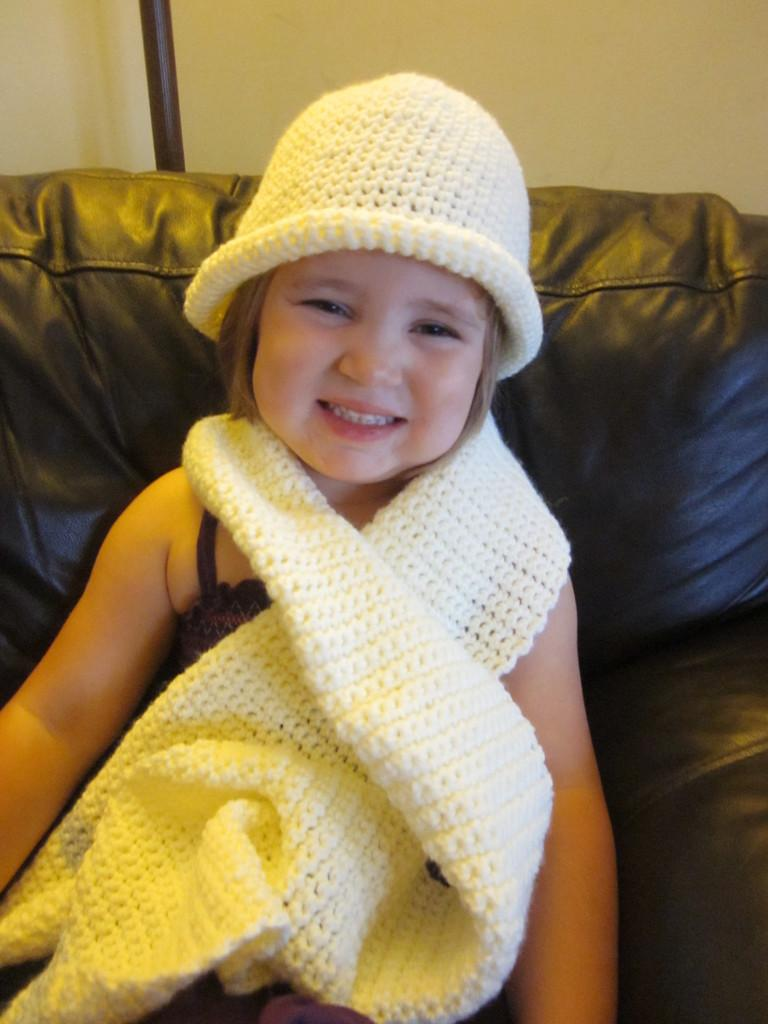Who is the main subject in the image? There is a girl in the image. What is the girl wearing? The girl is wearing a cap and a scarf. What is the girl's facial expression? The girl is smiling. Where is the girl sitting? The girl is sitting on a couch. What can be seen in the background of the image? There is a wall in the background of the image. What type of bait is the girl using to catch fish in the image? There is no indication in the image that the girl is using bait or attempting to catch fish. What does the girl's voice sound like in the image? The image is a still photograph and does not capture sound, so it is impossible to determine the girl's voice. 